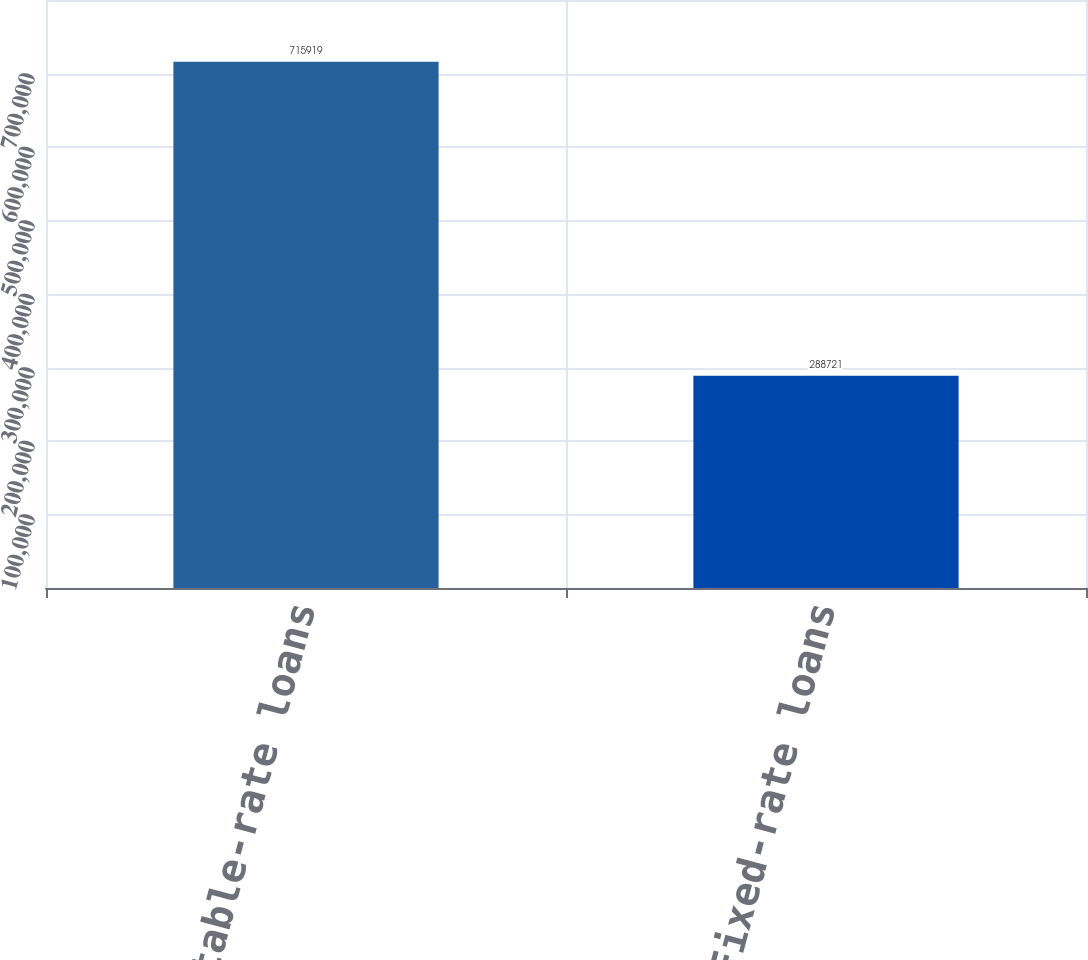Convert chart to OTSL. <chart><loc_0><loc_0><loc_500><loc_500><bar_chart><fcel>Adjustable-rate loans<fcel>Fixed-rate loans<nl><fcel>715919<fcel>288721<nl></chart> 